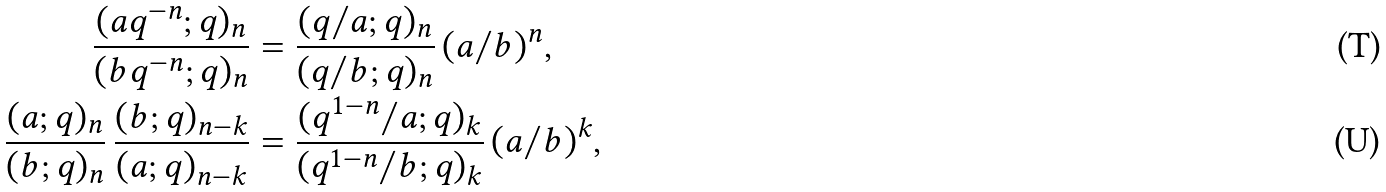Convert formula to latex. <formula><loc_0><loc_0><loc_500><loc_500>\frac { ( a q ^ { - n } ; q ) _ { n } } { ( b q ^ { - n } ; q ) _ { n } } & = \frac { ( q / a ; q ) _ { n } } { ( q / b ; q ) _ { n } } \, ( a / b ) ^ { n } , \\ \frac { ( a ; q ) _ { n } } { ( b ; q ) _ { n } } \, \frac { ( b ; q ) _ { n - k } } { ( a ; q ) _ { n - k } } & = \frac { ( q ^ { 1 - n } / a ; q ) _ { k } } { ( q ^ { 1 - n } / b ; q ) _ { k } } \, ( a / b ) ^ { k } ,</formula> 